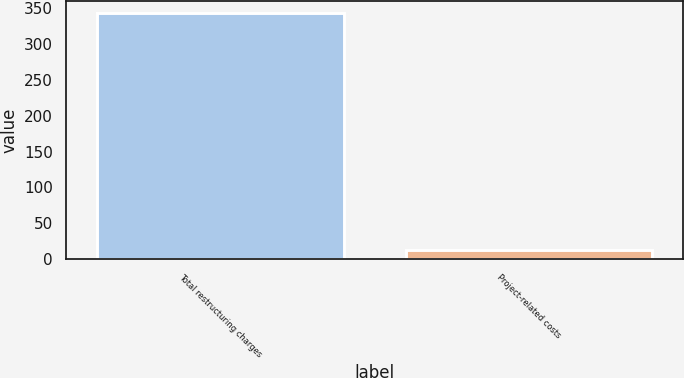Convert chart to OTSL. <chart><loc_0><loc_0><loc_500><loc_500><bar_chart><fcel>Total restructuring charges<fcel>Project-related costs<nl><fcel>343.5<fcel>13.2<nl></chart> 